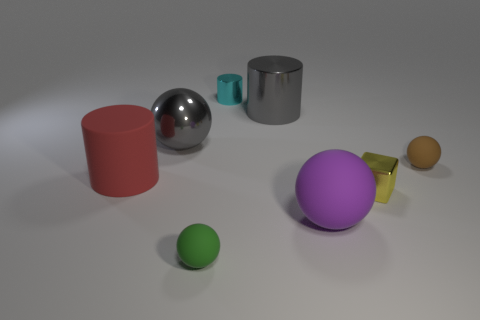Add 1 small green metallic things. How many objects exist? 9 Subtract all cylinders. How many objects are left? 5 Subtract all tiny purple rubber objects. Subtract all yellow metal objects. How many objects are left? 7 Add 2 rubber things. How many rubber things are left? 6 Add 3 gray shiny cylinders. How many gray shiny cylinders exist? 4 Subtract 1 brown spheres. How many objects are left? 7 